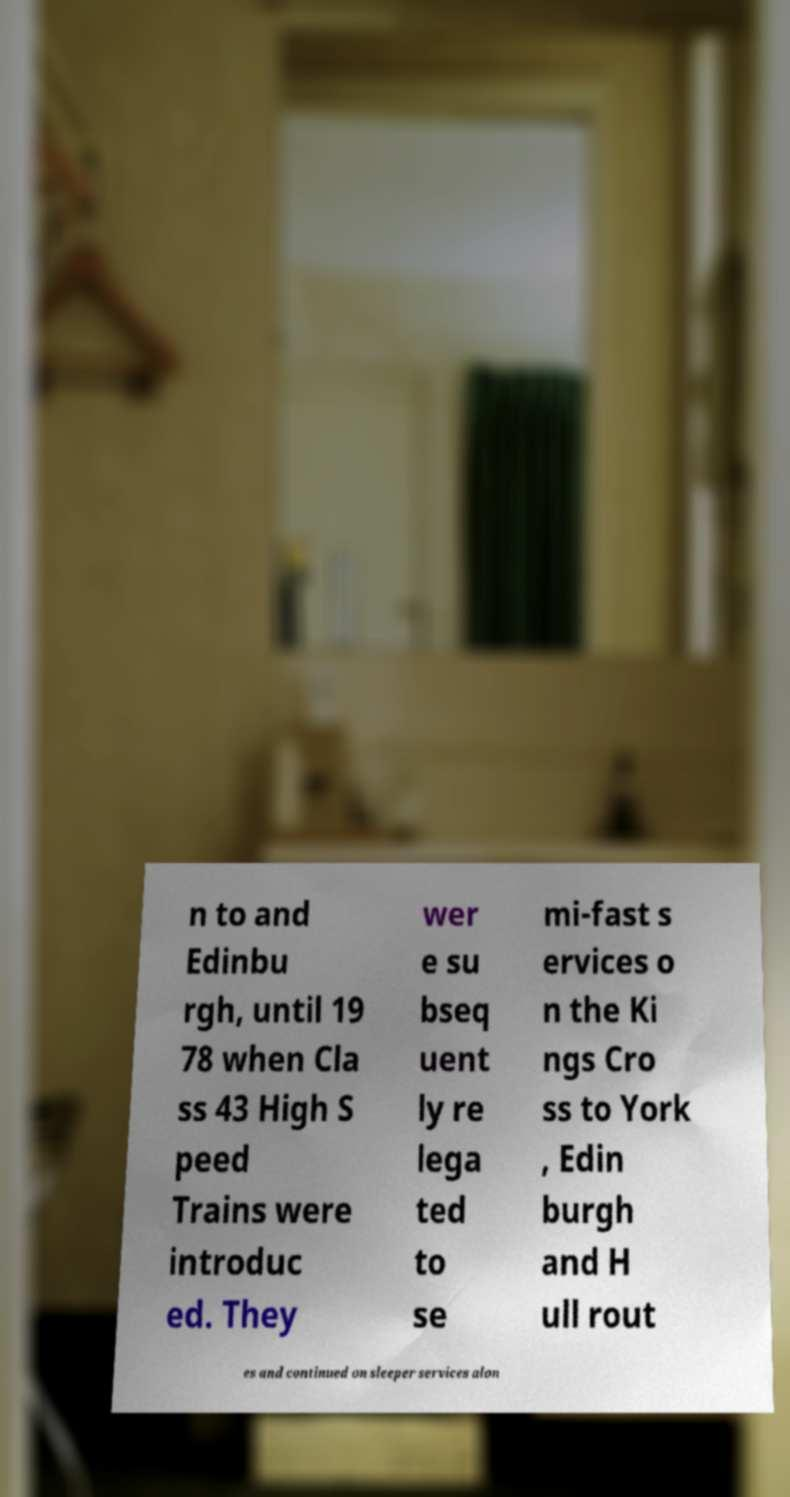Can you accurately transcribe the text from the provided image for me? n to and Edinbu rgh, until 19 78 when Cla ss 43 High S peed Trains were introduc ed. They wer e su bseq uent ly re lega ted to se mi-fast s ervices o n the Ki ngs Cro ss to York , Edin burgh and H ull rout es and continued on sleeper services alon 